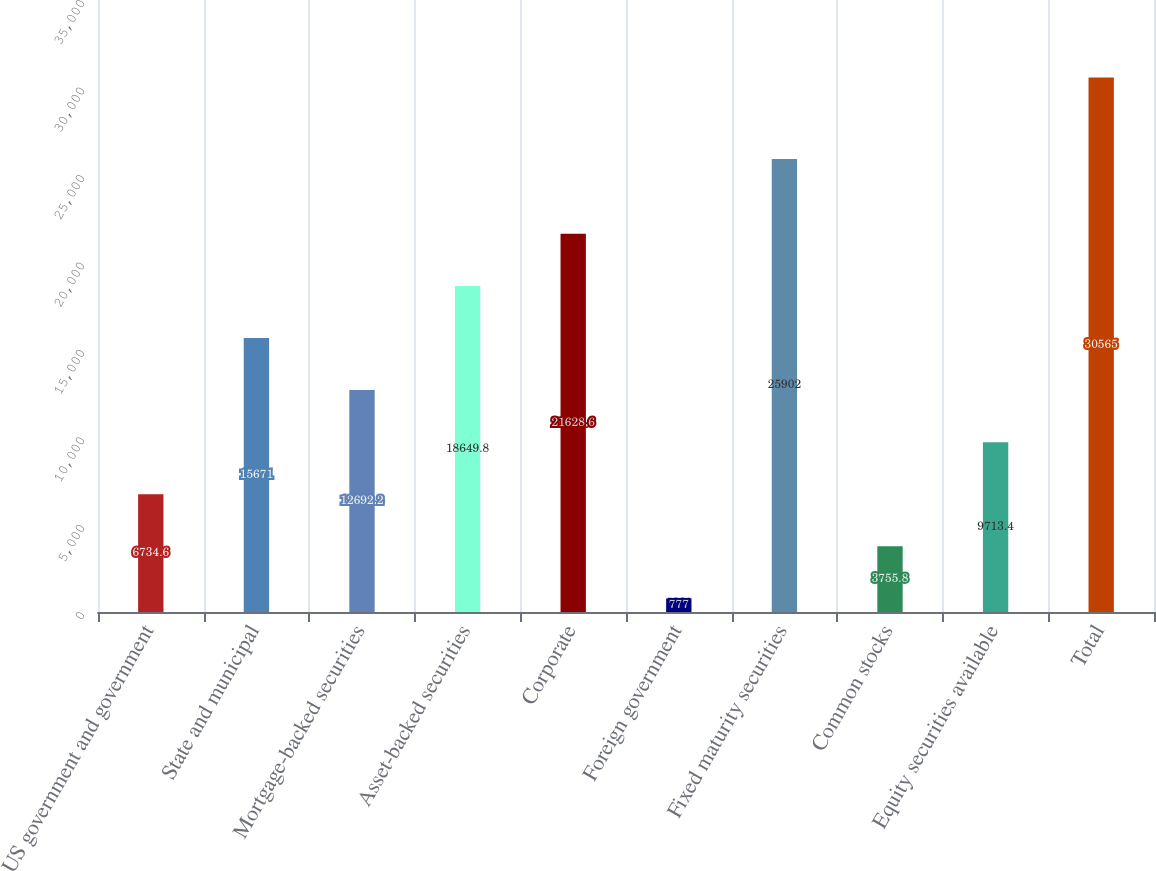Convert chart to OTSL. <chart><loc_0><loc_0><loc_500><loc_500><bar_chart><fcel>US government and government<fcel>State and municipal<fcel>Mortgage-backed securities<fcel>Asset-backed securities<fcel>Corporate<fcel>Foreign government<fcel>Fixed maturity securities<fcel>Common stocks<fcel>Equity securities available<fcel>Total<nl><fcel>6734.6<fcel>15671<fcel>12692.2<fcel>18649.8<fcel>21628.6<fcel>777<fcel>25902<fcel>3755.8<fcel>9713.4<fcel>30565<nl></chart> 